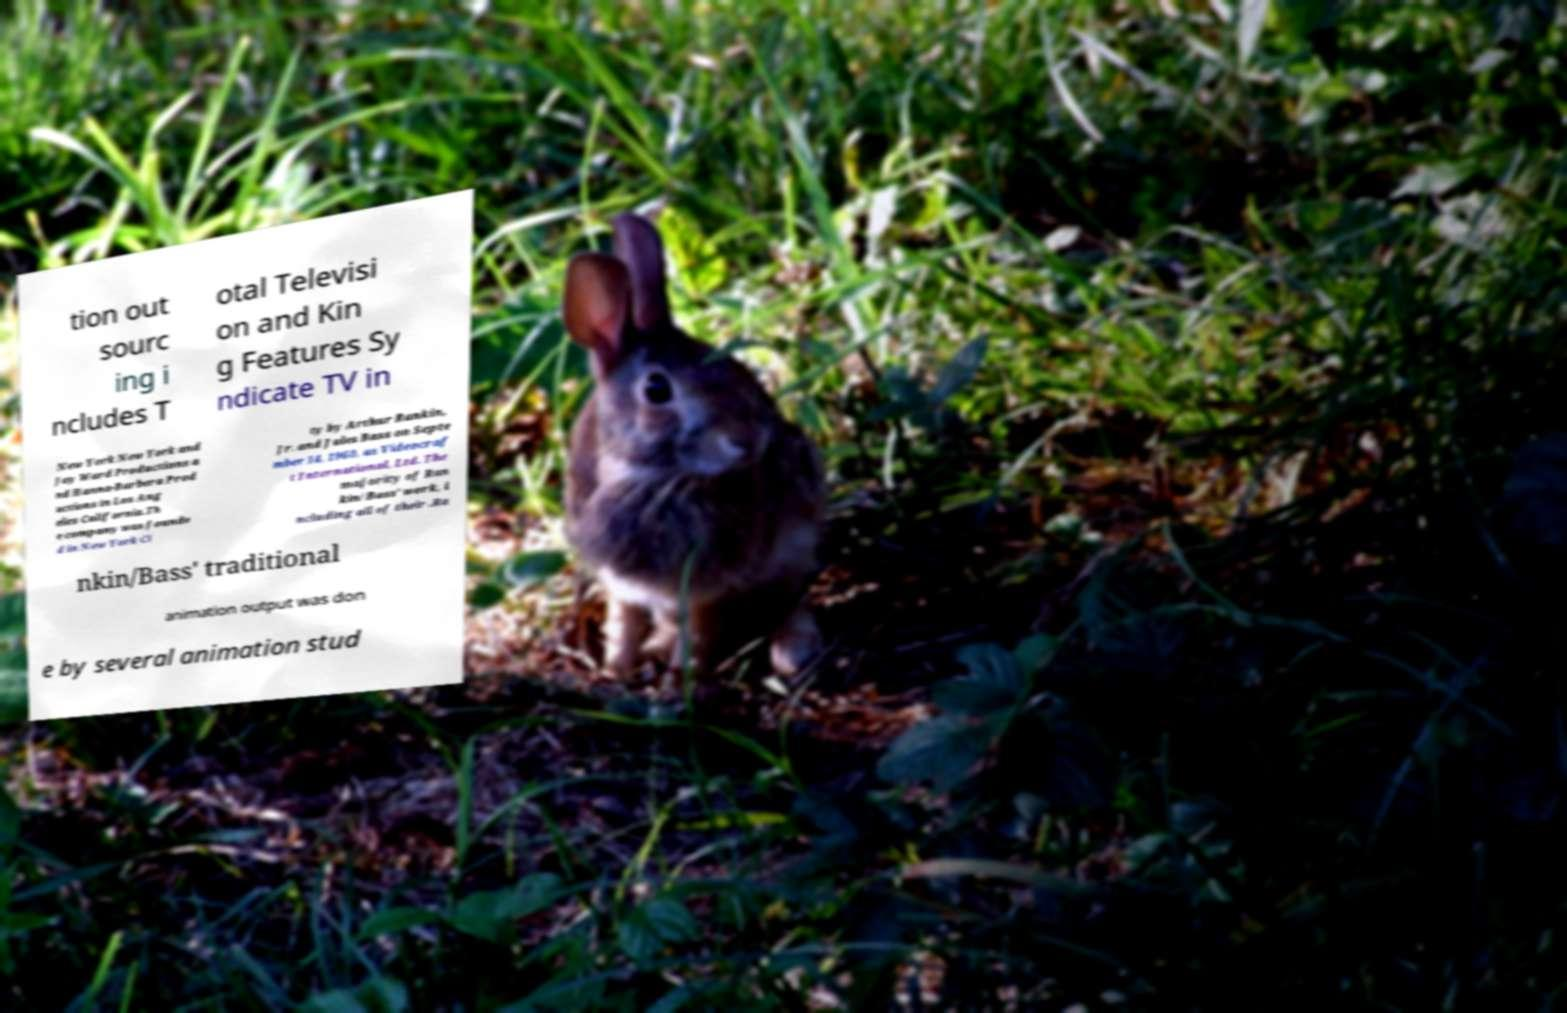Please read and relay the text visible in this image. What does it say? tion out sourc ing i ncludes T otal Televisi on and Kin g Features Sy ndicate TV in New York New York and Jay Ward Productions a nd Hanna-Barbera Prod uctions in Los Ang eles California.Th e company was founde d in New York Ci ty by Arthur Rankin, Jr. and Jules Bass on Septe mber 14, 1960, as Videocraf t International, Ltd. The majority of Ran kin/Bass' work, i ncluding all of their .Ra nkin/Bass' traditional animation output was don e by several animation stud 